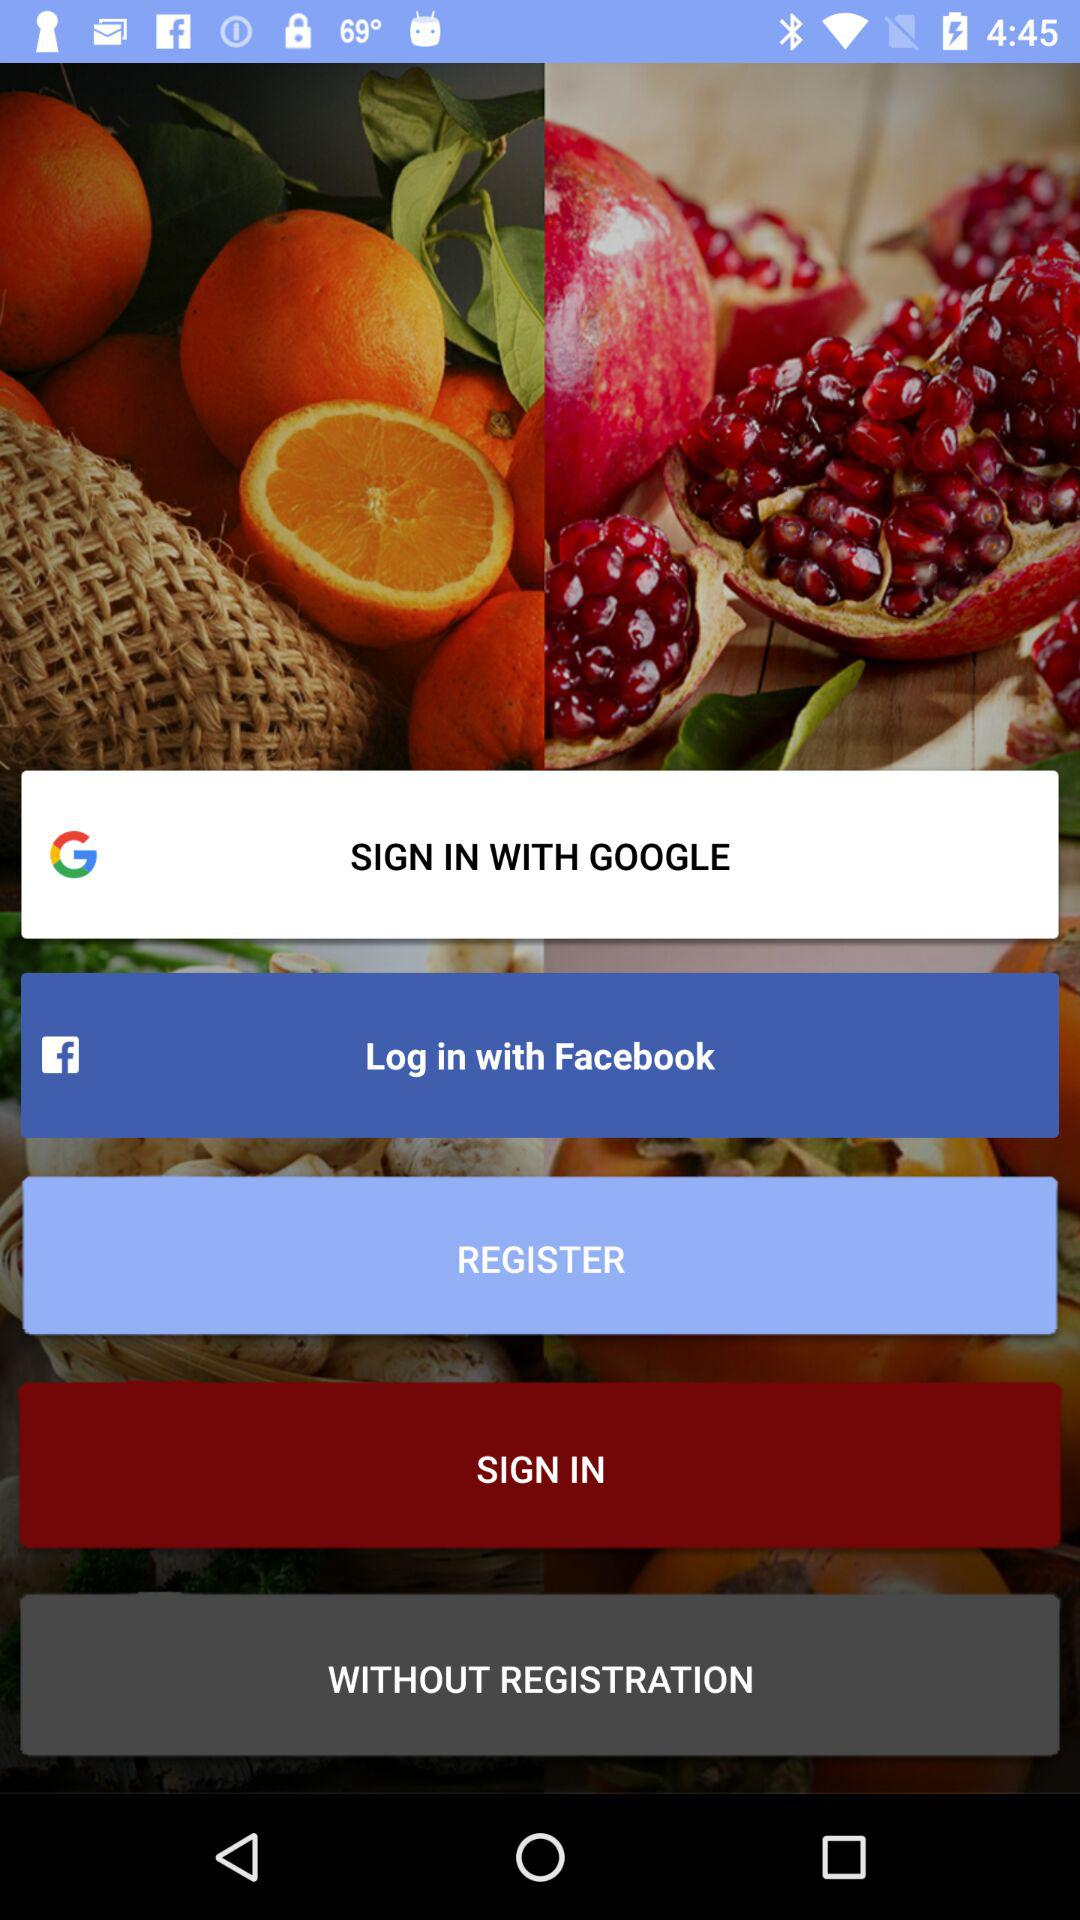What are the login options? The login options are "GOOGLE" and "Facebook". 